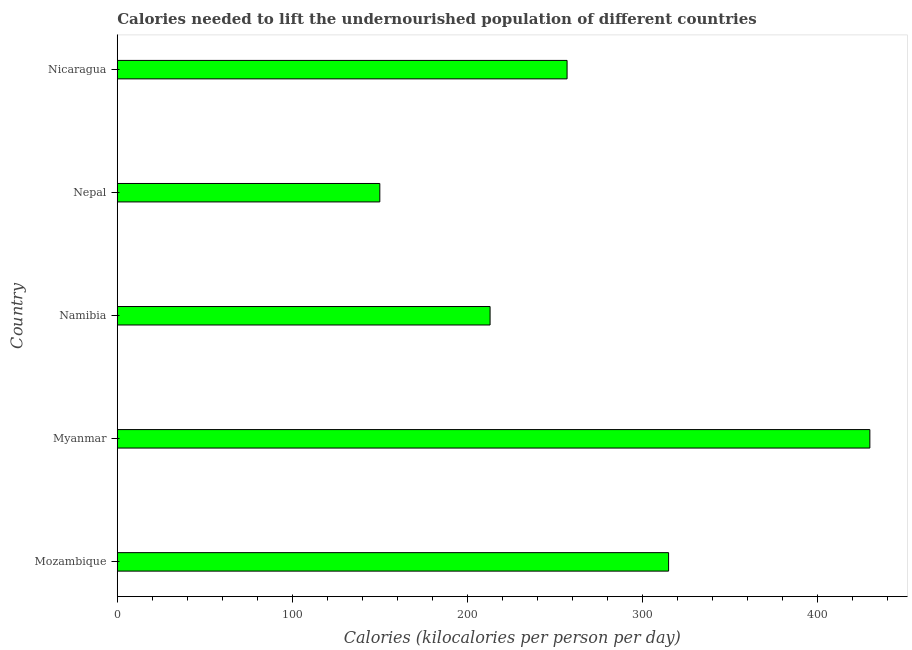What is the title of the graph?
Offer a very short reply. Calories needed to lift the undernourished population of different countries. What is the label or title of the X-axis?
Your response must be concise. Calories (kilocalories per person per day). What is the label or title of the Y-axis?
Offer a very short reply. Country. What is the depth of food deficit in Nepal?
Make the answer very short. 150. Across all countries, what is the maximum depth of food deficit?
Offer a terse response. 430. Across all countries, what is the minimum depth of food deficit?
Ensure brevity in your answer.  150. In which country was the depth of food deficit maximum?
Provide a succinct answer. Myanmar. In which country was the depth of food deficit minimum?
Your response must be concise. Nepal. What is the sum of the depth of food deficit?
Your answer should be very brief. 1365. What is the average depth of food deficit per country?
Provide a succinct answer. 273. What is the median depth of food deficit?
Provide a succinct answer. 257. What is the ratio of the depth of food deficit in Myanmar to that in Namibia?
Offer a terse response. 2.02. Is the depth of food deficit in Mozambique less than that in Nicaragua?
Provide a short and direct response. No. Is the difference between the depth of food deficit in Myanmar and Namibia greater than the difference between any two countries?
Make the answer very short. No. What is the difference between the highest and the second highest depth of food deficit?
Ensure brevity in your answer.  115. What is the difference between the highest and the lowest depth of food deficit?
Offer a terse response. 280. In how many countries, is the depth of food deficit greater than the average depth of food deficit taken over all countries?
Offer a very short reply. 2. How many bars are there?
Keep it short and to the point. 5. How many countries are there in the graph?
Give a very brief answer. 5. What is the difference between two consecutive major ticks on the X-axis?
Make the answer very short. 100. Are the values on the major ticks of X-axis written in scientific E-notation?
Your answer should be very brief. No. What is the Calories (kilocalories per person per day) of Mozambique?
Offer a very short reply. 315. What is the Calories (kilocalories per person per day) of Myanmar?
Your response must be concise. 430. What is the Calories (kilocalories per person per day) in Namibia?
Make the answer very short. 213. What is the Calories (kilocalories per person per day) of Nepal?
Your response must be concise. 150. What is the Calories (kilocalories per person per day) of Nicaragua?
Offer a terse response. 257. What is the difference between the Calories (kilocalories per person per day) in Mozambique and Myanmar?
Provide a succinct answer. -115. What is the difference between the Calories (kilocalories per person per day) in Mozambique and Namibia?
Your answer should be compact. 102. What is the difference between the Calories (kilocalories per person per day) in Mozambique and Nepal?
Offer a terse response. 165. What is the difference between the Calories (kilocalories per person per day) in Myanmar and Namibia?
Provide a succinct answer. 217. What is the difference between the Calories (kilocalories per person per day) in Myanmar and Nepal?
Offer a very short reply. 280. What is the difference between the Calories (kilocalories per person per day) in Myanmar and Nicaragua?
Give a very brief answer. 173. What is the difference between the Calories (kilocalories per person per day) in Namibia and Nepal?
Ensure brevity in your answer.  63. What is the difference between the Calories (kilocalories per person per day) in Namibia and Nicaragua?
Offer a terse response. -44. What is the difference between the Calories (kilocalories per person per day) in Nepal and Nicaragua?
Your response must be concise. -107. What is the ratio of the Calories (kilocalories per person per day) in Mozambique to that in Myanmar?
Your answer should be compact. 0.73. What is the ratio of the Calories (kilocalories per person per day) in Mozambique to that in Namibia?
Give a very brief answer. 1.48. What is the ratio of the Calories (kilocalories per person per day) in Mozambique to that in Nepal?
Make the answer very short. 2.1. What is the ratio of the Calories (kilocalories per person per day) in Mozambique to that in Nicaragua?
Your answer should be compact. 1.23. What is the ratio of the Calories (kilocalories per person per day) in Myanmar to that in Namibia?
Your answer should be very brief. 2.02. What is the ratio of the Calories (kilocalories per person per day) in Myanmar to that in Nepal?
Make the answer very short. 2.87. What is the ratio of the Calories (kilocalories per person per day) in Myanmar to that in Nicaragua?
Ensure brevity in your answer.  1.67. What is the ratio of the Calories (kilocalories per person per day) in Namibia to that in Nepal?
Ensure brevity in your answer.  1.42. What is the ratio of the Calories (kilocalories per person per day) in Namibia to that in Nicaragua?
Provide a succinct answer. 0.83. What is the ratio of the Calories (kilocalories per person per day) in Nepal to that in Nicaragua?
Your answer should be compact. 0.58. 